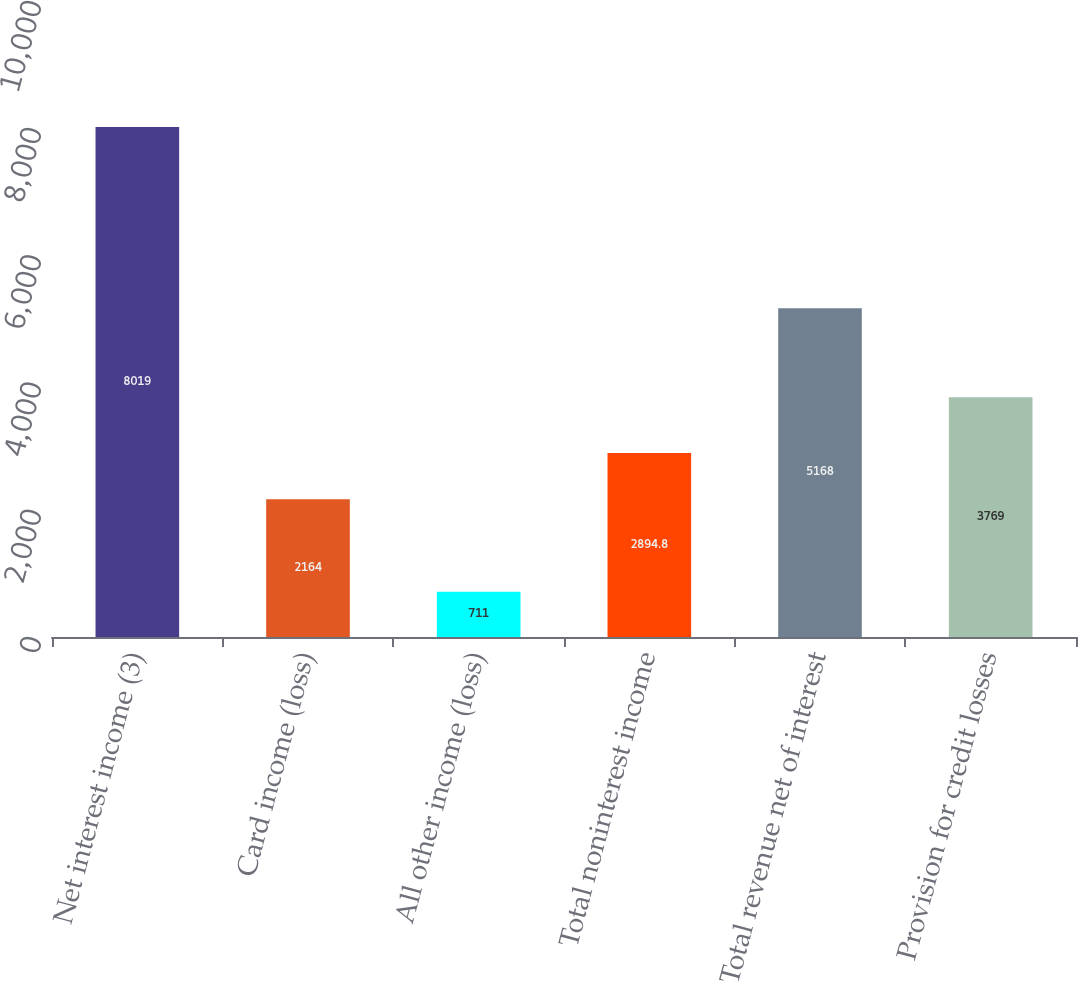Convert chart. <chart><loc_0><loc_0><loc_500><loc_500><bar_chart><fcel>Net interest income (3)<fcel>Card income (loss)<fcel>All other income (loss)<fcel>Total noninterest income<fcel>Total revenue net of interest<fcel>Provision for credit losses<nl><fcel>8019<fcel>2164<fcel>711<fcel>2894.8<fcel>5168<fcel>3769<nl></chart> 